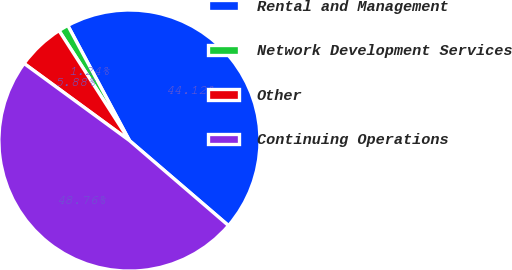Convert chart to OTSL. <chart><loc_0><loc_0><loc_500><loc_500><pie_chart><fcel>Rental and Management<fcel>Network Development Services<fcel>Other<fcel>Continuing Operations<nl><fcel>44.12%<fcel>1.24%<fcel>5.88%<fcel>48.76%<nl></chart> 